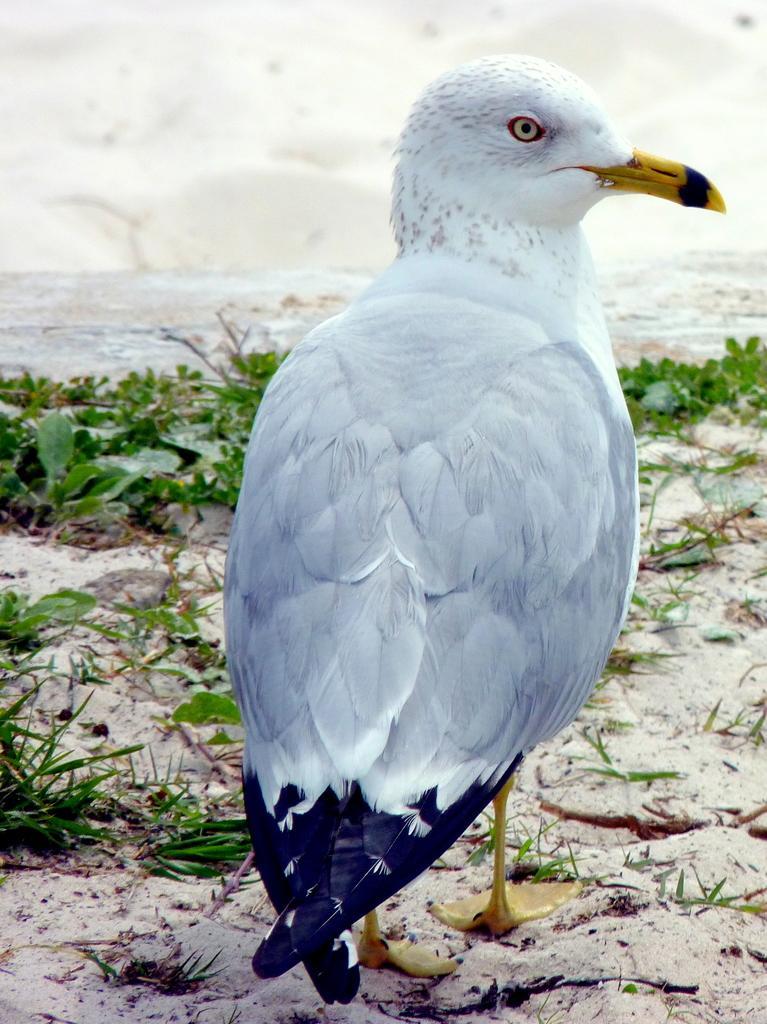In one or two sentences, can you explain what this image depicts? In this image we can see a bird on the ground and there are plants, water and a white background. 